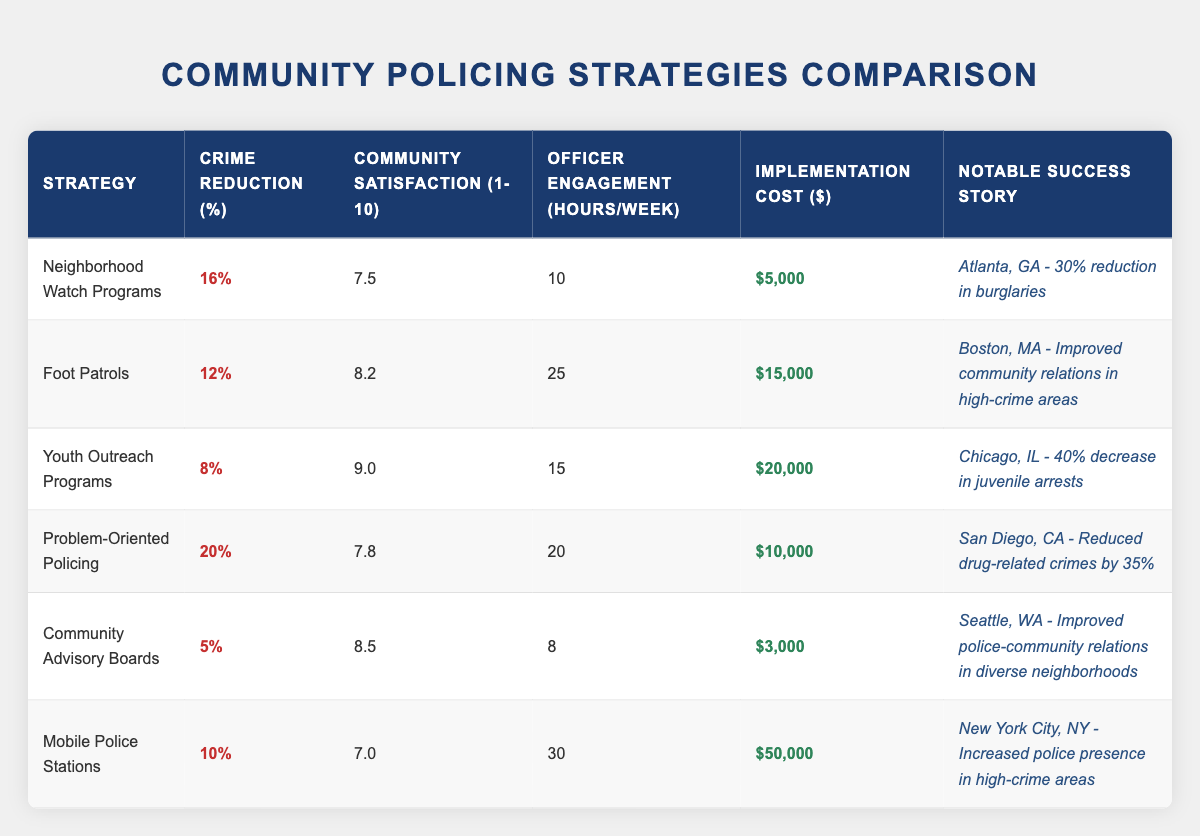What's the crime reduction percentage for Neighborhood Watch Programs? The table shows that Neighborhood Watch Programs have a crime reduction of 16%.
Answer: 16% Which community policing strategy has the highest community satisfaction rating? The highest community satisfaction rating of 9.0 is for Youth Outreach Programs.
Answer: Youth Outreach Programs What is the implementation cost of Mobile Police Stations? According to the table, the implementation cost for Mobile Police Stations is $50,000.
Answer: $50,000 What is the average crime reduction percentage across all strategies? To find the average, we add the crime reduction percentages: 16 + 12 + 8 + 20 + 5 + 10 = 71. There are 6 strategies, so the average is 71/6 = 11.83%.
Answer: 11.83% Is the community satisfaction for Foot Patrols greater than 8? The table shows that Foot Patrols have a community satisfaction rating of 8.2, which is greater than 8.
Answer: Yes Which strategy offers the lowest implementation cost? The implementation cost for Community Advisory Boards is $3,000, which is the lowest in the table.
Answer: Community Advisory Boards What is the total number of officer engagement hours per week for all strategies combined? We need to sum the officer engagement hours for each strategy: 10 + 25 + 15 + 20 + 8 + 30 = 108.
Answer: 108 How does the crime reduction of Problem-Oriented Policing compare to Youth Outreach Programs? Problem-Oriented Policing has a crime reduction of 20%, while Youth Outreach Programs have a reduction of 8%. Thus, Problem-Oriented Policing's reduction is significantly higher.
Answer: Higher Is there a success story associated with Community Advisory Boards? Yes, the success story for Community Advisory Boards is about improved police-community relations in diverse neighborhoods in Seattle, WA.
Answer: Yes 